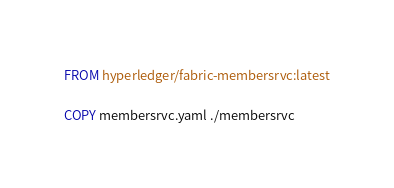Convert code to text. <code><loc_0><loc_0><loc_500><loc_500><_Dockerfile_>FROM hyperledger/fabric-membersrvc:latest

COPY membersrvc.yaml ./membersrvc</code> 